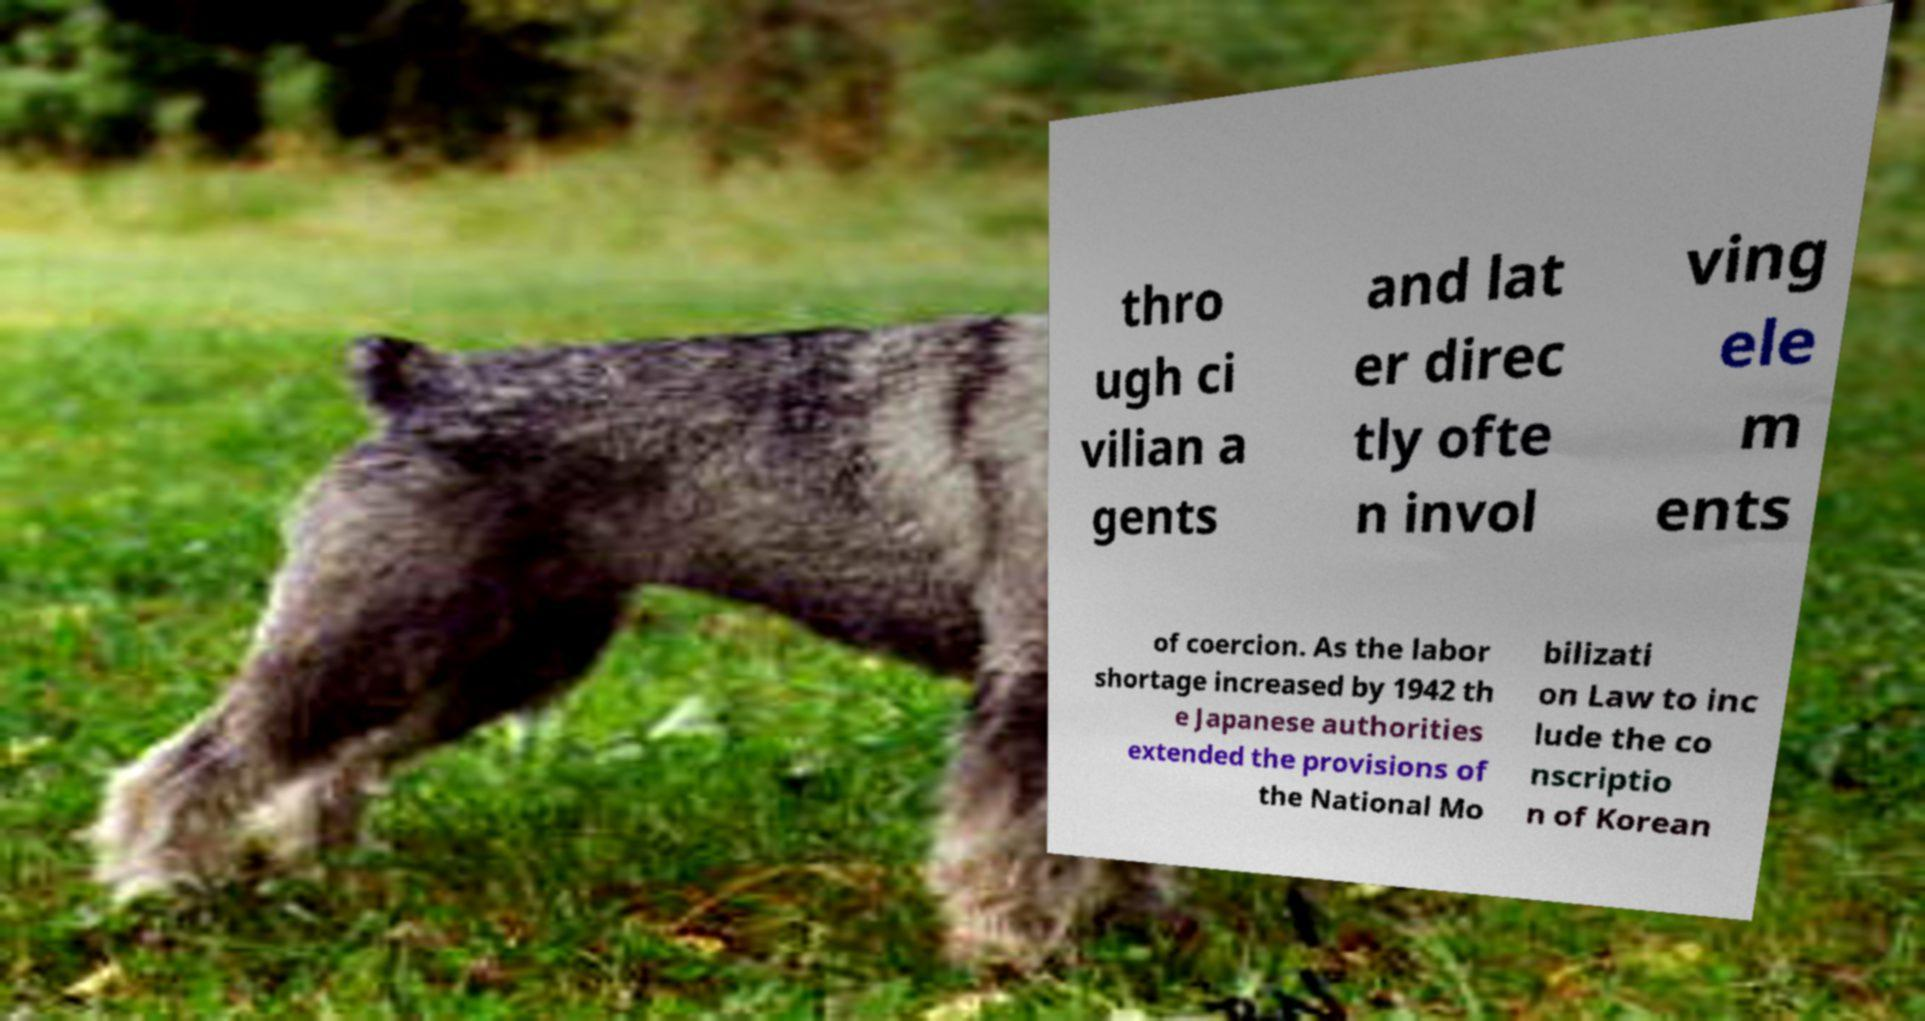Please identify and transcribe the text found in this image. thro ugh ci vilian a gents and lat er direc tly ofte n invol ving ele m ents of coercion. As the labor shortage increased by 1942 th e Japanese authorities extended the provisions of the National Mo bilizati on Law to inc lude the co nscriptio n of Korean 